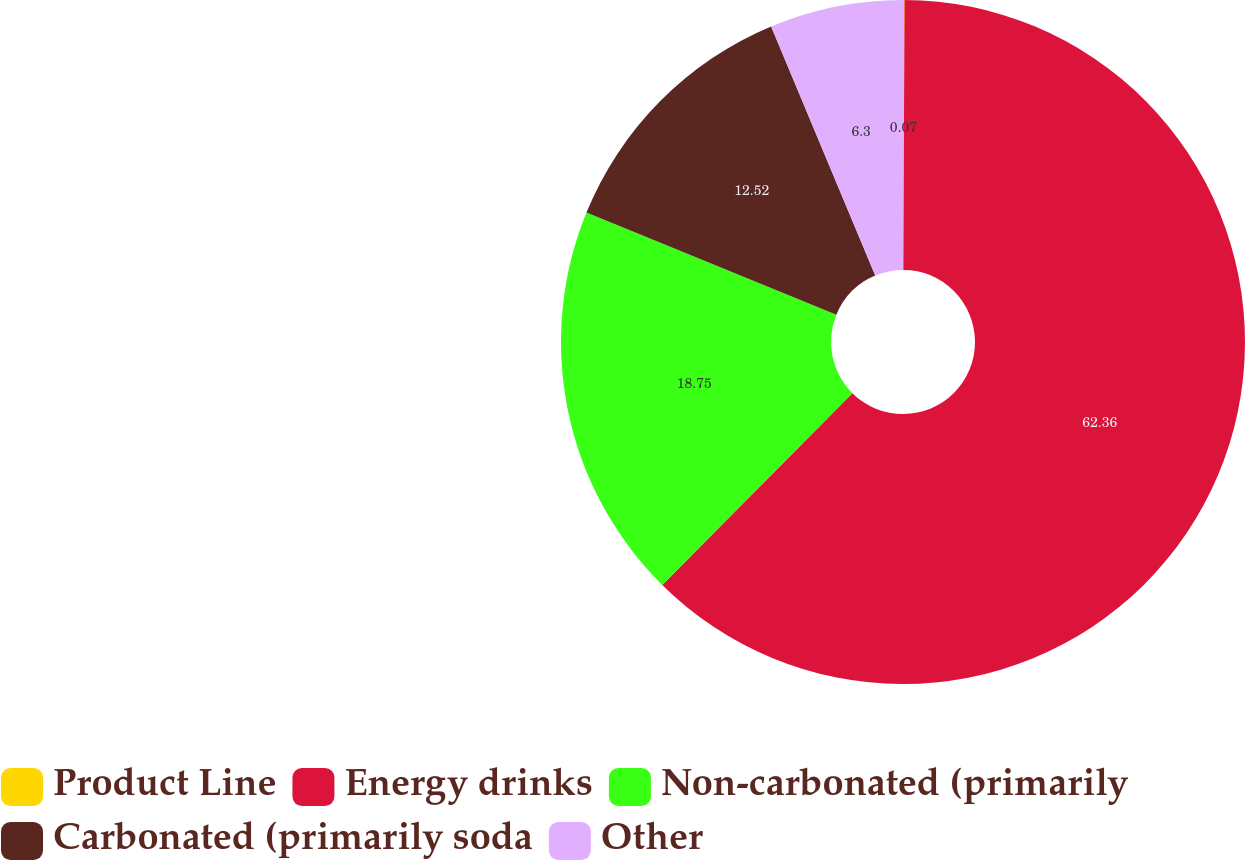<chart> <loc_0><loc_0><loc_500><loc_500><pie_chart><fcel>Product Line<fcel>Energy drinks<fcel>Non-carbonated (primarily<fcel>Carbonated (primarily soda<fcel>Other<nl><fcel>0.07%<fcel>62.36%<fcel>18.75%<fcel>12.52%<fcel>6.3%<nl></chart> 